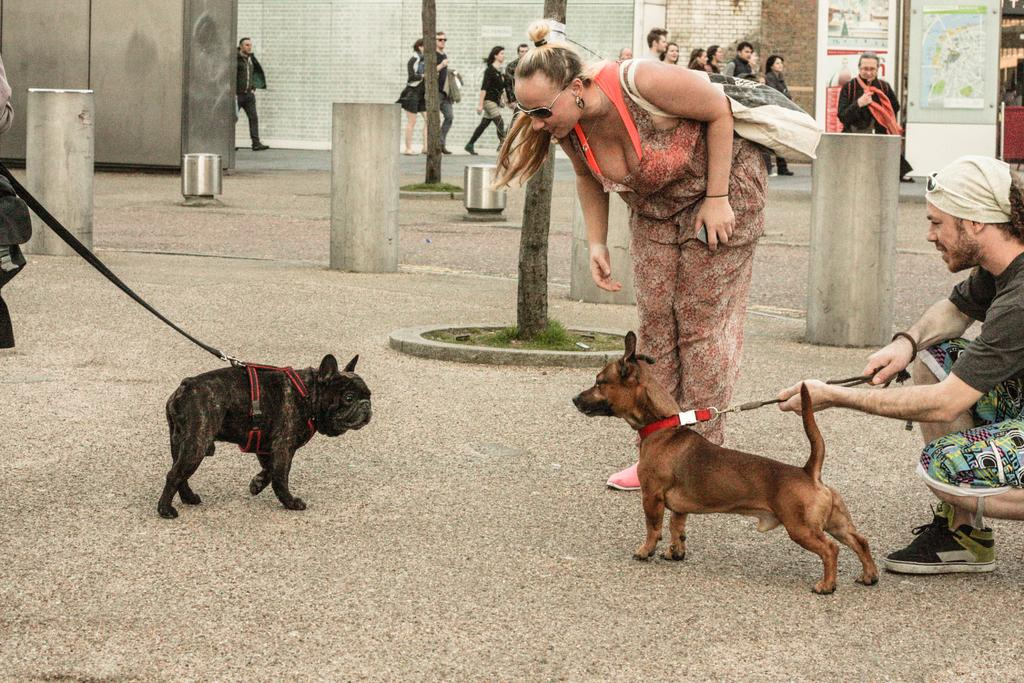How many people are in the image? There are people in the image, but the exact number is not specified. What animals are present in the image? There are two dogs in the image. Can you describe the appearance of one of the people in the image? A woman is wearing black shades in the image. What is the woman teaching the dogs in the image? There is no indication in the image that the woman is teaching the dogs anything. What process is being carried out in the image? The image does not depict a process; it simply shows people and dogs. 